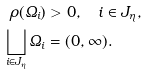<formula> <loc_0><loc_0><loc_500><loc_500>\rho ( \varOmega _ { i } ) & > 0 , \quad i \in J _ { \eta } , \\ \bigsqcup _ { i \in J _ { \eta } } \varOmega _ { i } & = ( 0 , \infty ) .</formula> 